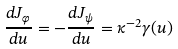Convert formula to latex. <formula><loc_0><loc_0><loc_500><loc_500>\frac { d J _ { \varphi } } { d u } = - \frac { d J _ { \psi } } { d u } = \kappa ^ { - 2 } \gamma ( u )</formula> 